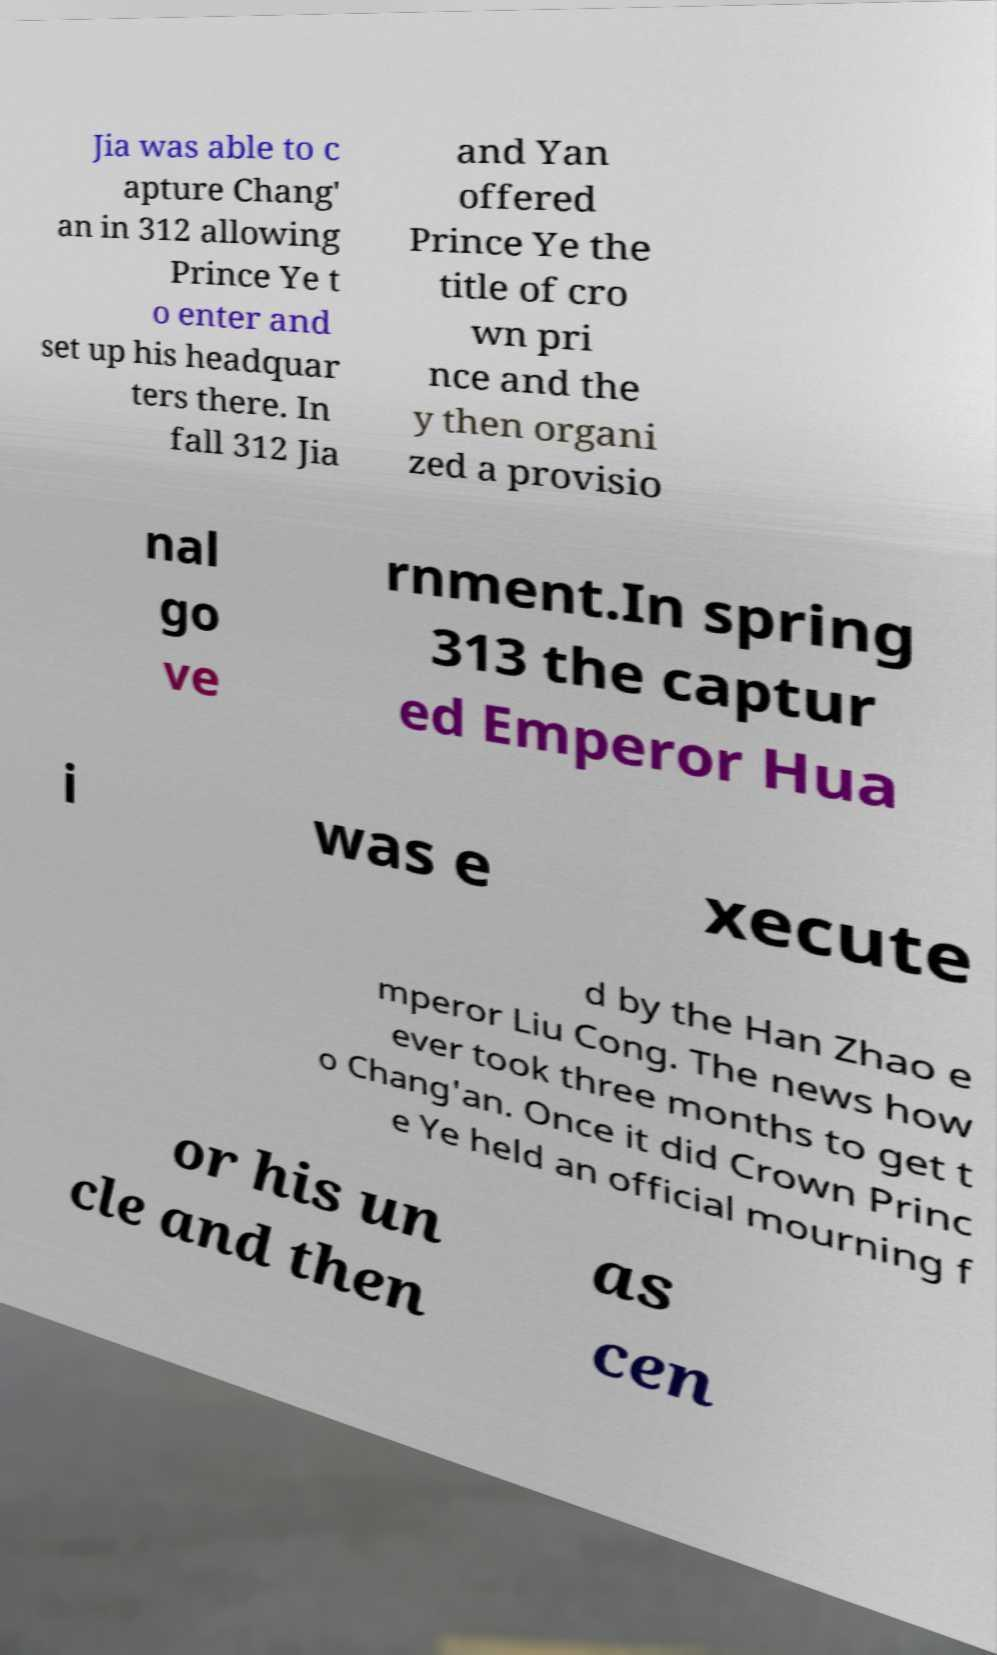There's text embedded in this image that I need extracted. Can you transcribe it verbatim? Jia was able to c apture Chang' an in 312 allowing Prince Ye t o enter and set up his headquar ters there. In fall 312 Jia and Yan offered Prince Ye the title of cro wn pri nce and the y then organi zed a provisio nal go ve rnment.In spring 313 the captur ed Emperor Hua i was e xecute d by the Han Zhao e mperor Liu Cong. The news how ever took three months to get t o Chang'an. Once it did Crown Princ e Ye held an official mourning f or his un cle and then as cen 